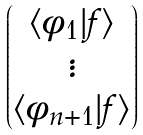Convert formula to latex. <formula><loc_0><loc_0><loc_500><loc_500>\begin{pmatrix} \langle \phi _ { 1 } | f \rangle \\ \vdots \\ \langle \phi _ { n + 1 } | f \rangle \end{pmatrix}</formula> 